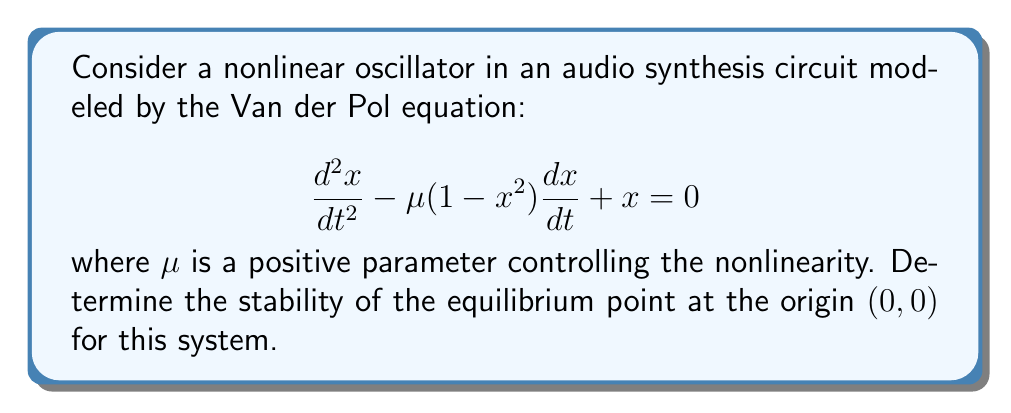Can you solve this math problem? To analyze the stability of the equilibrium point at the origin, we'll follow these steps:

1) First, rewrite the second-order differential equation as a system of first-order equations:

   Let $y = \frac{dx}{dt}$, then:
   $$\frac{dx}{dt} = y$$
   $$\frac{dy}{dt} = \mu(1-x^2)y - x$$

2) The equilibrium point $(0,0)$ satisfies:
   $$\frac{dx}{dt} = 0 \implies y = 0$$
   $$\frac{dy}{dt} = 0 \implies \mu(1-x^2)y - x = 0 \implies x = 0$$

3) To determine stability, we need to linearize the system around $(0,0)$. Calculate the Jacobian matrix:

   $$J = \begin{bmatrix}
   \frac{\partial}{\partial x}(\frac{dx}{dt}) & \frac{\partial}{\partial y}(\frac{dx}{dt}) \\
   \frac{\partial}{\partial x}(\frac{dy}{dt}) & \frac{\partial}{\partial y}(\frac{dy}{dt})
   \end{bmatrix}$$

   $$J = \begin{bmatrix}
   0 & 1 \\
   -2\mu xy - 1 & \mu(1-x^2)
   \end{bmatrix}$$

4) Evaluate the Jacobian at $(0,0)$:

   $$J_{(0,0)} = \begin{bmatrix}
   0 & 1 \\
   -1 & \mu
   \end{bmatrix}$$

5) Calculate the eigenvalues $\lambda$ of $J_{(0,0)}$:

   $$det(J_{(0,0)} - \lambda I) = \begin{vmatrix}
   -\lambda & 1 \\
   -1 & \mu - \lambda
   \end{vmatrix} = 0$$

   $$\lambda^2 - \mu\lambda + 1 = 0$$

6) Solve the characteristic equation:

   $$\lambda = \frac{\mu \pm \sqrt{\mu^2 - 4}}{2}$$

7) Analyze the eigenvalues:
   - If $\mu < 2$, both eigenvalues have negative real parts.
   - If $\mu > 2$, one eigenvalue has a positive real part.
   - If $\mu = 2$, we have purely imaginary eigenvalues.

Therefore, the equilibrium point $(0,0)$ is:
- Stable for $0 < \mu < 2$
- Unstable for $\mu > 2$
- Marginally stable (center) for $\mu = 2$
Answer: Stable for $0 < \mu < 2$, unstable for $\mu > 2$, marginally stable for $\mu = 2$. 